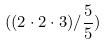Convert formula to latex. <formula><loc_0><loc_0><loc_500><loc_500>( ( 2 \cdot 2 \cdot 3 ) / \frac { 5 } { 5 } )</formula> 